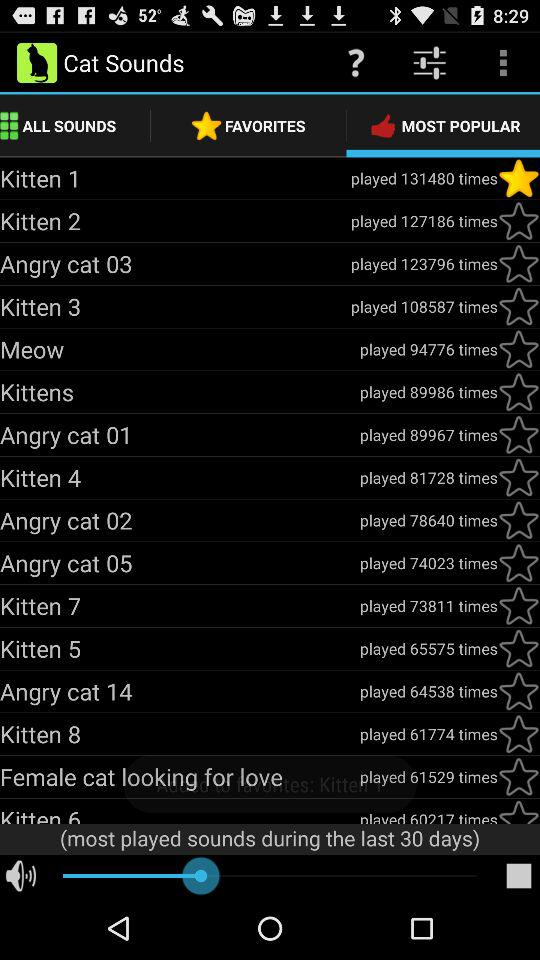What is the name of the application? The name of the application is "Cat Sounds". 